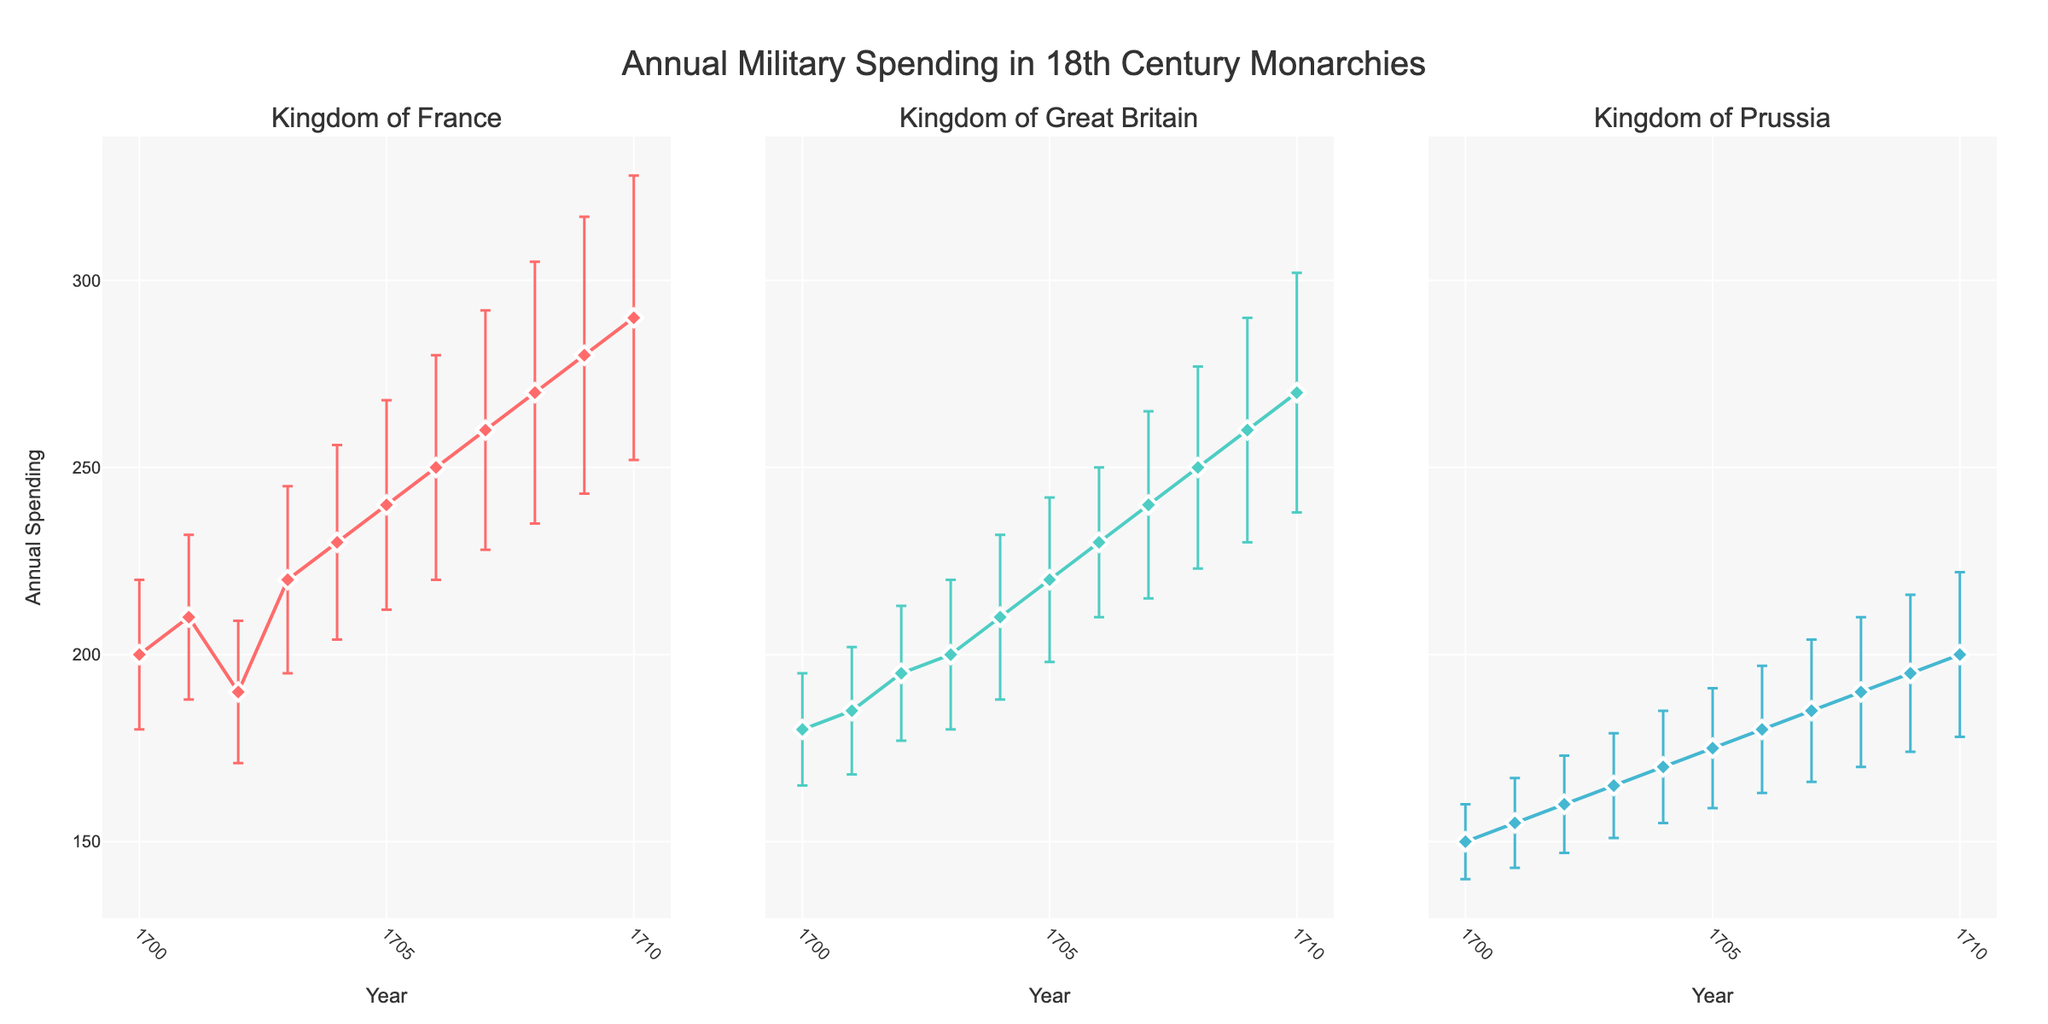How many monarchies are shown in the subplots? Each subplot is titled with the name of a monarchy. Counting the unique titles present in the subplots will give us the number of monarchies.
Answer: 3 Which monarchy had the highest military spending in 1710? By looking at the data points for 1710 across all three subplots, we compare the annual spending amounts. The Kingdom of France has the highest value at 290.
Answer: Kingdom of France Between 1700 and 1705, which monarchy had the lowest variability in spending? Variability can be observed by the length of the error bars. The shortest average error bars in this period indicate the lowest variability, which is shown in the Kingdom of Prussia.
Answer: Kingdom of Prussia What trend can you observe for the Kingdom of Great Britain's military spending from 1700 to 1710? By following the plotted line for the Kingdom of Great Britain, we can see if the spending is increasing, decreasing, or staying constant over the years.
Answer: Increasing In what year did the Kingdom of Great Britain have military spending of 195? By finding the data point on the Kingdom of Great Britain subplot that matches the annual spending value of 195, we identify the corresponding year as 1702.
Answer: 1702 Which year does the Kingdom of France exhibit the maximum increase in annual spending compared to the previous year? We need to calculate the year-on-year difference in spending and find the maximum increase. The maximum increase occurs between 1707 (260) and 1708 (270), which is an increase of 10.
Answer: 1708 For the Kingdom of Prussia, what is the average spending over the decade displayed? We sum the spending values for the Kingdom of Prussia and divide by the number of years (11). (150 + 155 + 160 + 165 + 170 + 175 + 180 + 185 + 190 + 195 + 200) / 11 results in an average of 173.18.
Answer: 173.18 How does the variability (standard deviation) in military spending change over time for the Kingdom of France? By observing the changes in the length of the error bars for the Kingdom of France from 1700 to 1710, we note whether they generally increase, decrease, or remain stable over time. The error bars appear to increase, indicating growing variability.
Answer: Increasing 